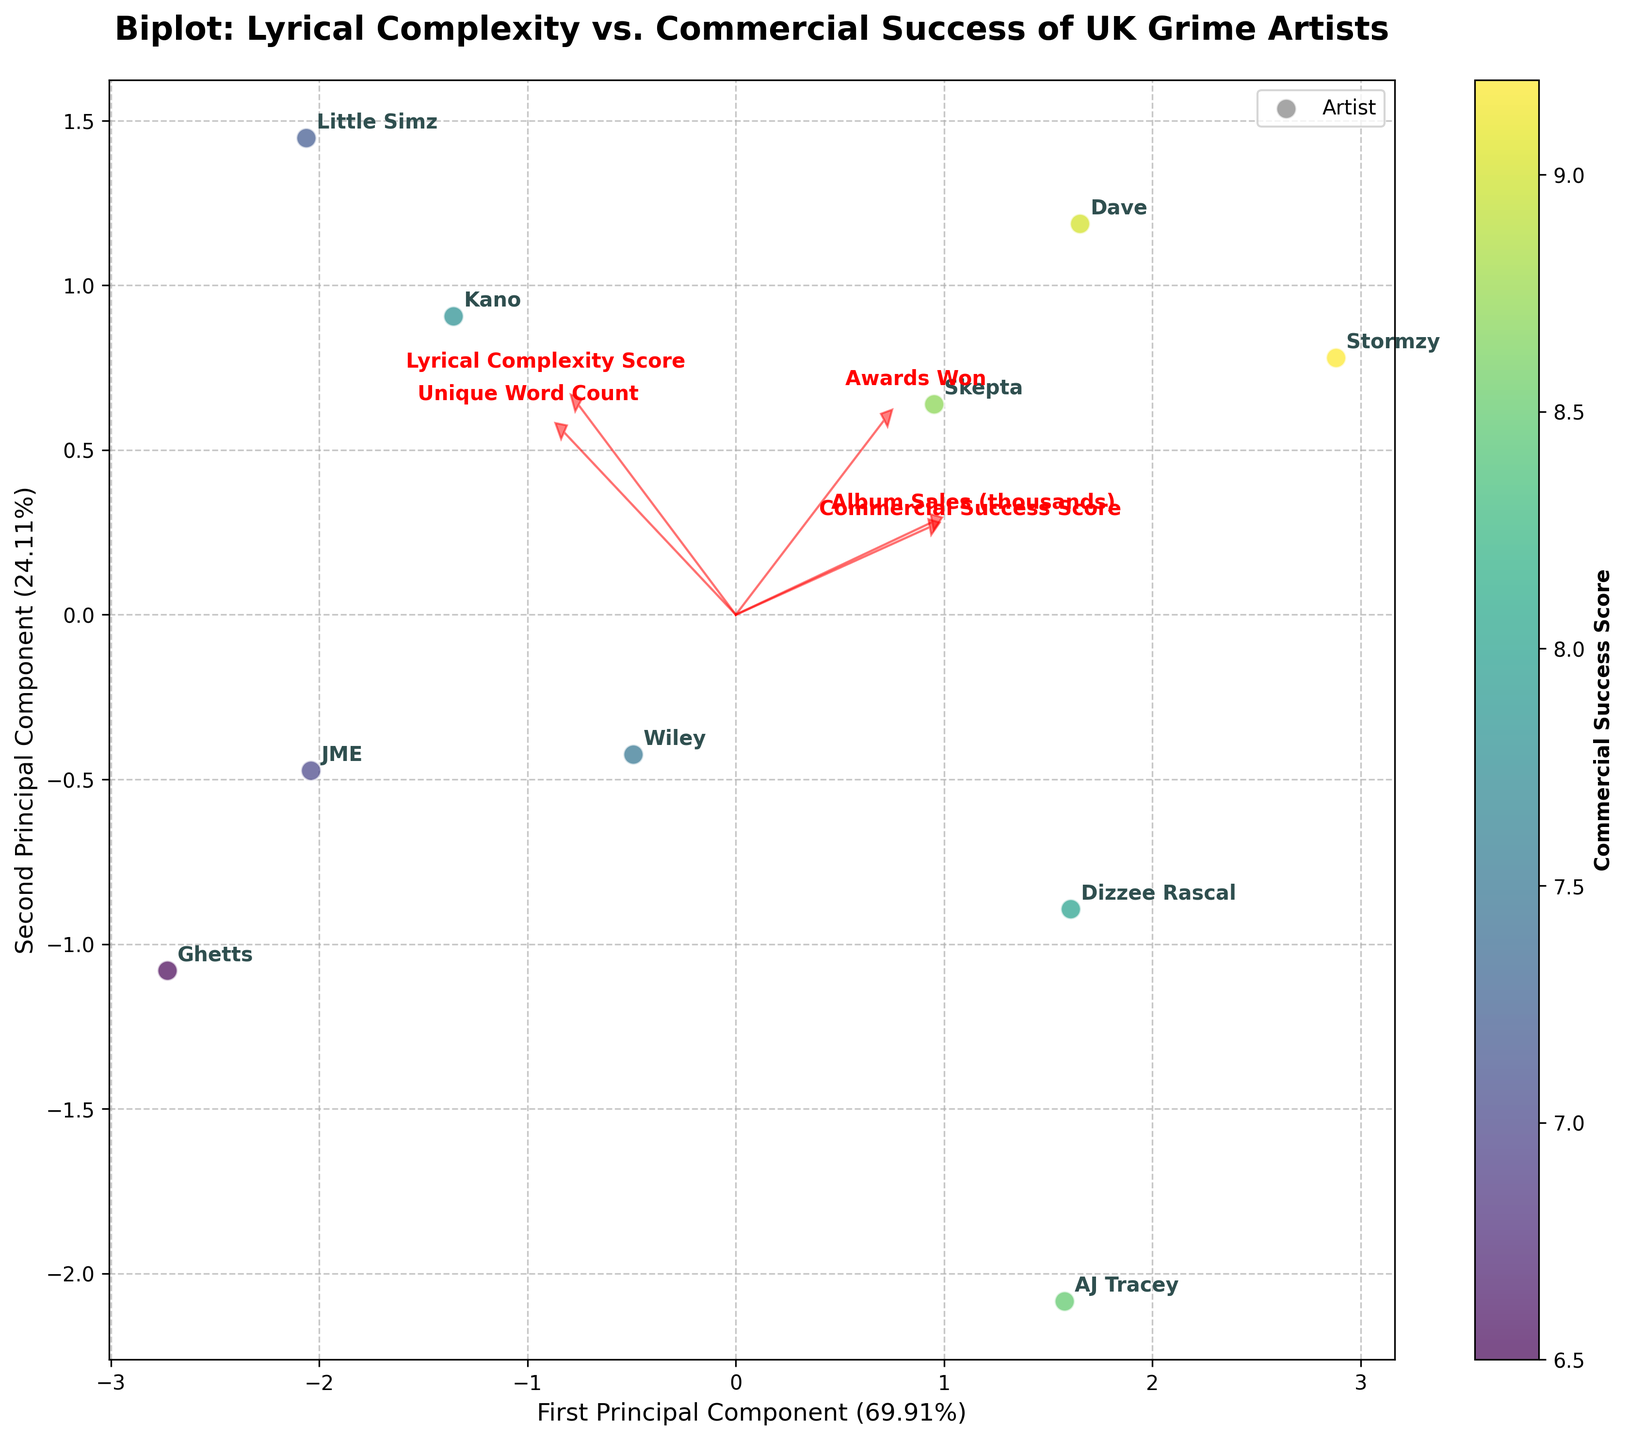Which artist has the highest Commercial Success Score? By examining the scatter points, the colorbar indicates that Stormzy has the highest Commercial Success Score with a score of 9.2.
Answer: Stormzy Which two artists have the highest scores for Lyrical Complexity? By analyzing the position of the scatter points along the first axis and referring to the artist labels, Little Simz (9.7) and Kano (9.5) have the highest Lyrical Complexity Scores.
Answer: Little Simz and Kano What is the relationship between Unique Word Count and Lyrical Complexity? The loadings arrows show that both Unique Word Count and Lyrical Complexity point in similar directions, indicating a strong positive correlation. As Lyrical Complexity increases, so does the Unique Word Count.
Answer: Positive correlation Which artist falls on the lowest range of the second principal component? By observing the scatter plot, Ghetts is the artist closest to the bottom of the second principal component axis.
Answer: Ghetts What feature seems least correlated with the first principal component? The arrows for the features on the biplot indicate their correlations with the principal components. "Album Sales (thousands)" is almost perpendicular to the first principal component, suggesting a weak or no correlation.
Answer: Album Sales (thousands) Among the artists with a Commercial Success Score above 8.5, who has the highest Lyrical Complexity Score? By looking at the scatter plot and color coding, Dave has a Commercial Success Score of 9.0, and his Lyrical Complexity Score of 9.1 is the highest among artists with a Commercial Success Score above 8.5.
Answer: Dave Which feature contributes most to the second principal component? By looking at the length and direction of the feature arrows, "Awards Won" has the longest arrow pointing strongly in the direction of the second principal component, indicating it is the most contributing feature.
Answer: Awards Won How are the artists clustered in relation to Commercial Success Score? Artists with darker color points (high Commercial Success Score) such as Stormzy and Dave cluster together on the upper part of the plot, indicating similarity in their success metrics.
Answer: Clustered in top right Which artist has the lowest Lyrical Complexity Score and what is their Commercial Success Score? By locating the scatter plot point closest to the origin on the Lyrical Complexity axis, AJ Tracey has the lowest Lyrical Complexity Score of 8.0. His Commercial Success Score is 8.5.
Answer: AJ Tracey, 8.5 